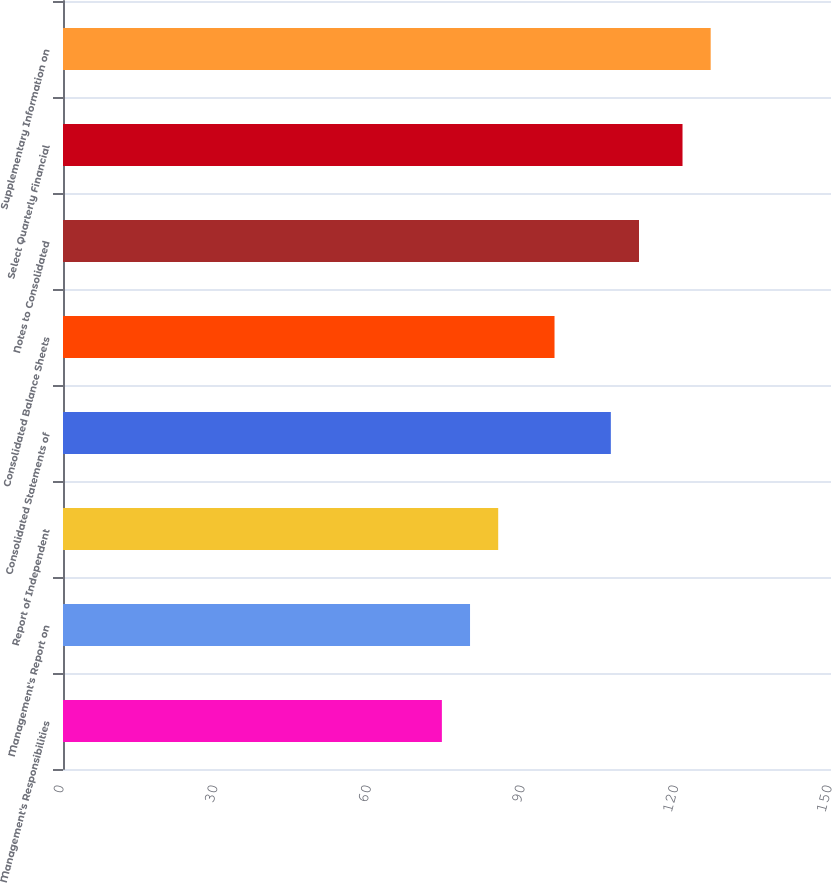Convert chart to OTSL. <chart><loc_0><loc_0><loc_500><loc_500><bar_chart><fcel>Management's Responsibilities<fcel>Management's Report on<fcel>Report of Independent<fcel>Consolidated Statements of<fcel>Consolidated Balance Sheets<fcel>Notes to Consolidated<fcel>Select Quarterly Financial<fcel>Supplementary Information on<nl><fcel>74<fcel>79.5<fcel>85<fcel>107<fcel>96<fcel>112.5<fcel>121<fcel>126.5<nl></chart> 